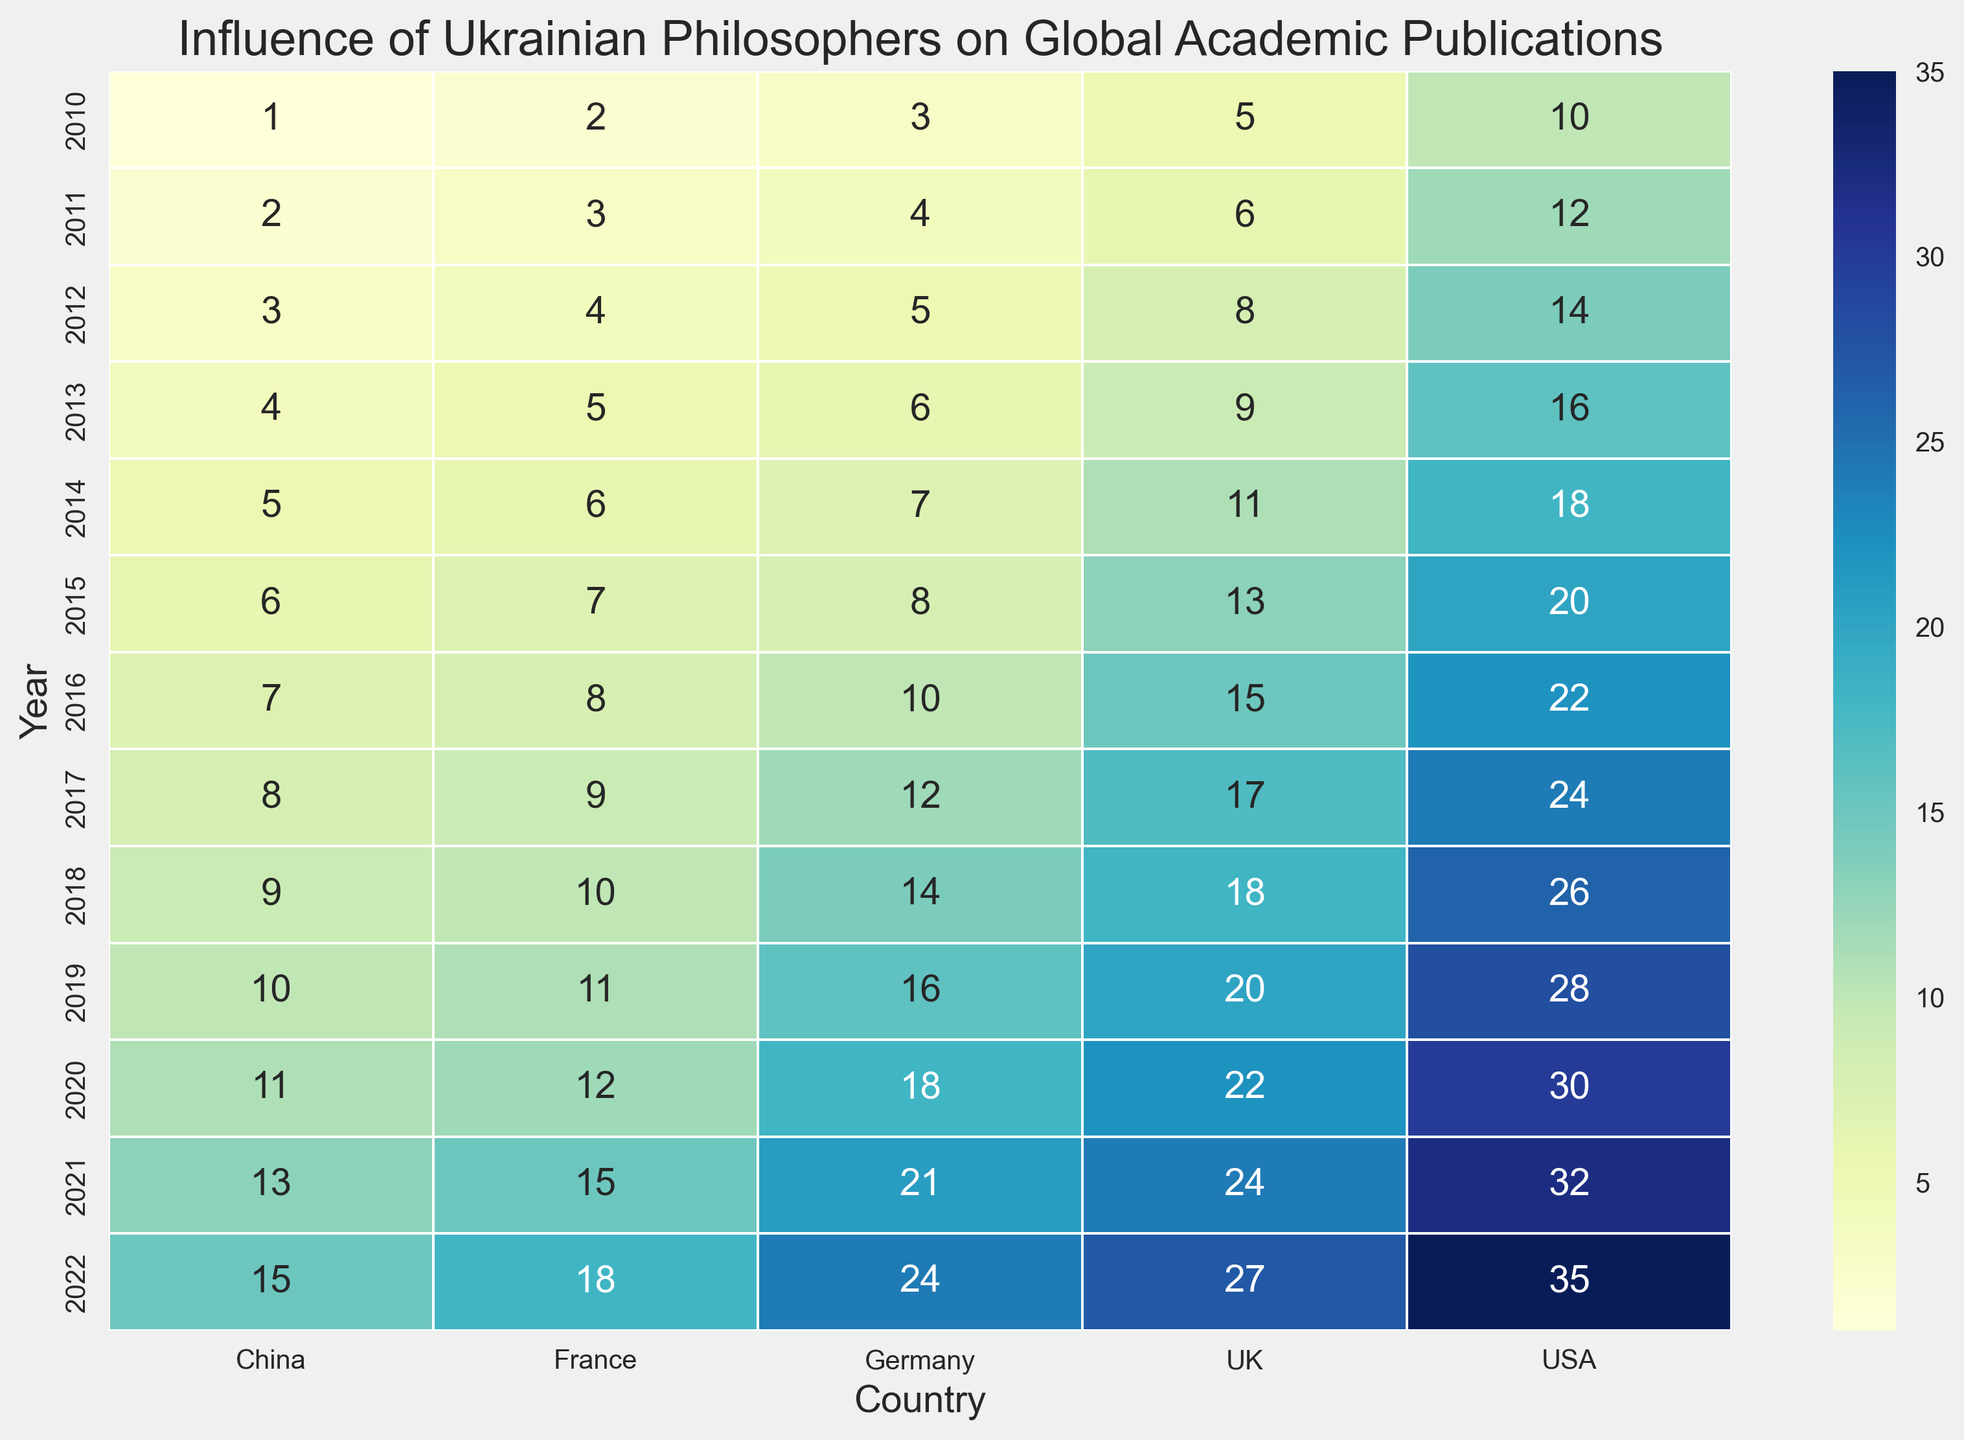Which country had the highest number of publications in 2022? Looking at the heatmap, observe the data corresponding to the year 2022; the country with the highest number is the USA with 35 publications.
Answer: USA In which year did the UK have more publications than Germany? Compare the publication numbers for the UK and Germany in each year. Starting from 2011, the UK consistently has more publications than Germany.
Answer: 2011 By how many publications did the number of USA publications increase from 2010 to 2020? Identify the USA's publication numbers for 2010 and 2020 in the heatmap, then subtract the 2010 number from the 2020 number: 30 (2020) - 10 (2010) = 20.
Answer: 20 What is the average number of publications for France from 2010 to 2022? Sum all the publication numbers for France from 2010 to 2022, then divide by the number of years (13). Total: 2+3+4+5+6+7+8+9+10+11+12+15+18 = 100. Average: 100/13 ≈ 7.69.
Answer: 7.69 In which year did China first have double-digit publications? Observe the publication numbers for China; they reach double digits (10 or more) in 2019.
Answer: 2019 How many total publications were there across all countries in 2015? Sum the publication numbers in the heatmap for the year 2015: 20 (USA) + 13 (UK) + 8 (Germany) + 7 (France) + 6 (China) = 54.
Answer: 54 What is the difference between the number of publications by the USA and Germany in 2016? Identify the publication numbers for the USA and Germany in 2016 and subtract the German number from the USA number: 22 (USA) - 10 (Germany) = 12.
Answer: 12 Which country showed the greatest increase in publications from 2017 to 2018? Calculate the increase for each country from 2017 to 2018 and compare them. Increases: USA: 26-24=2, UK: 18-17=1, Germany: 14-12=2, France: 10-9=1, China: 9-8=1. The USA and Germany both have the greatest increase of 2 publications.
Answer: USA and Germany In which years did France have a single-digit number of publications? Observe the years for France showing less than 10 publications in the heatmap: 2010 to 2013 and 2017.
Answer: 2010, 2011, 2012, 2013, 2017 What was the sum of publications for all the countries in 2022? Sum the publication numbers for 2022: 35 (USA) + 27 (UK) + 24 (Germany) + 18 (France) + 15 (China) = 119.
Answer: 119 